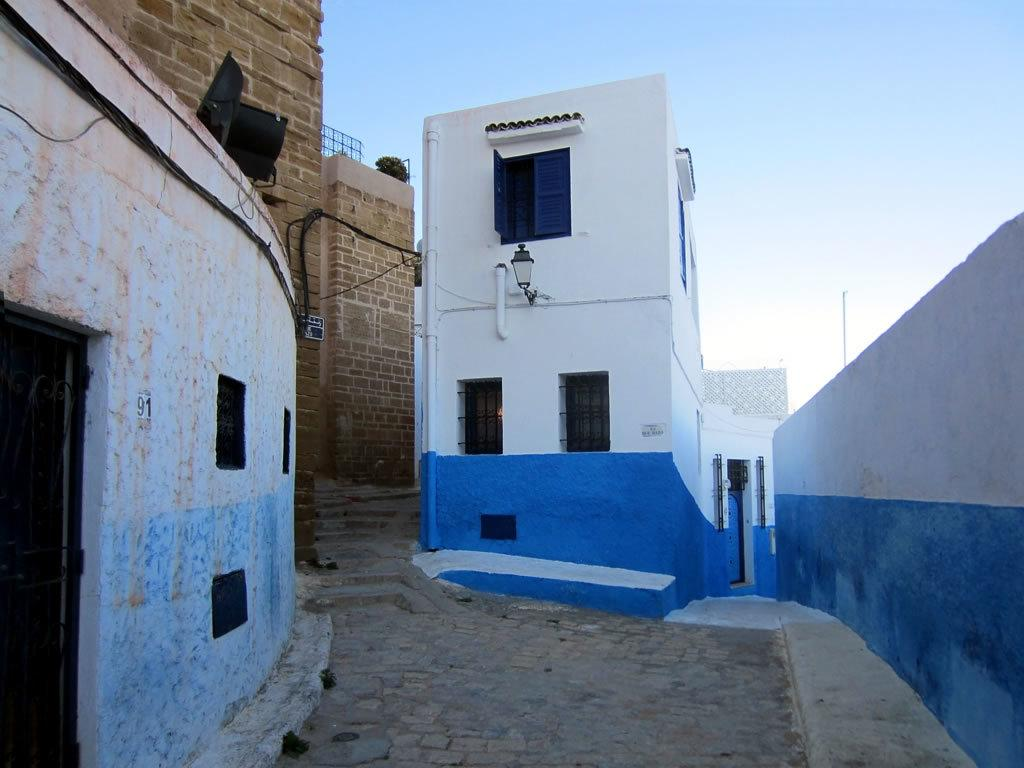What type of structures are present in the image? There are buildings in the image. Can you describe any specific features of the buildings? A light is attached to one of the buildings. What is located to the right of the image? There is a wall to the right of the image. What can be seen in the background of the image? There is a pole and the sky visible in the background of the image. What type of pan is being used to cook food in the image? There is no pan or cooking activity present in the image. Can you tell me where the camera is located in the image? There is no camera visible in the image. 